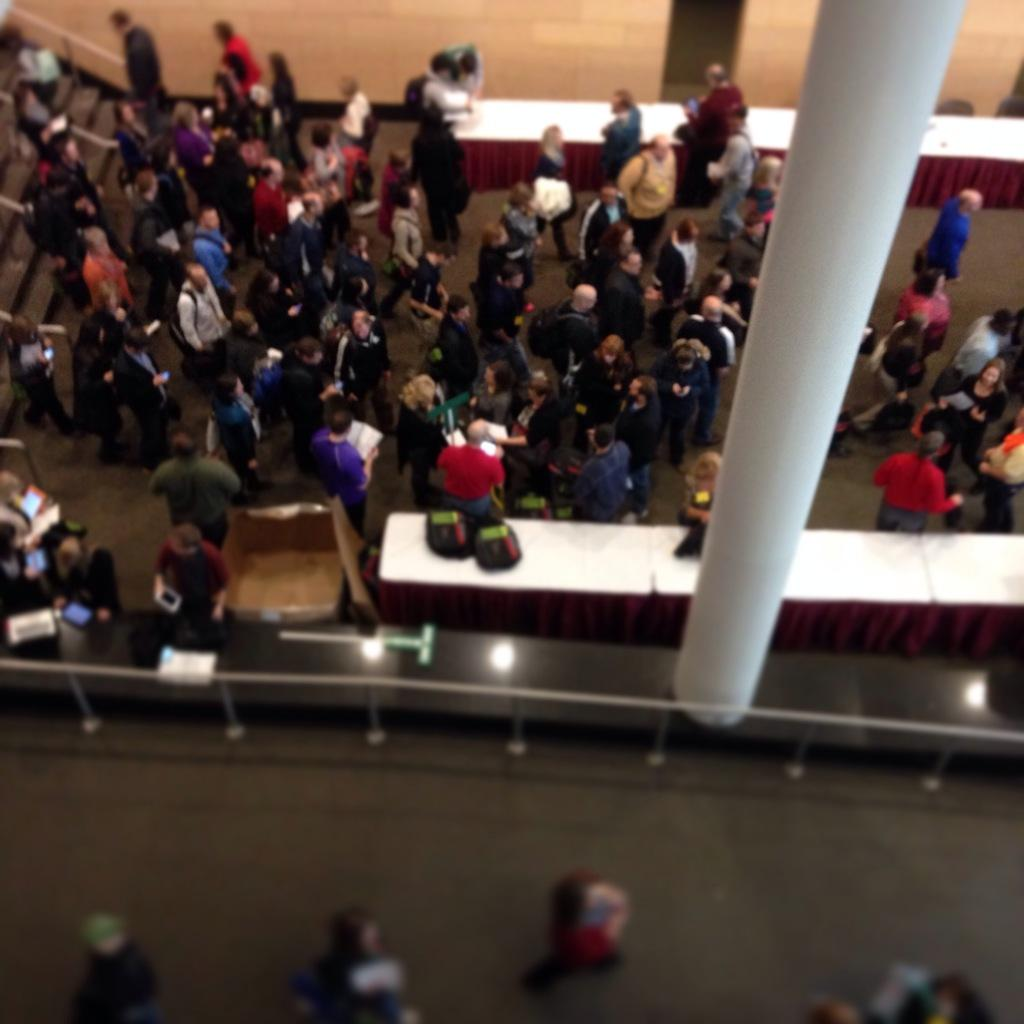What are the people in the image doing? The people in the image are walking. What can be seen in the background of the image? There is a white pillar in the image. How many tables are visible in the image? There are two tables in the image. What architectural feature is on the left side of the image? There are stairs on the left side of the image. What type of lace can be seen on the legs of the people in the image? There is no lace visible on the people's legs in the image. Where is the faucet located in the image? There is no faucet present in the image. 